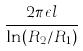<formula> <loc_0><loc_0><loc_500><loc_500>\frac { 2 \pi \epsilon l } { \ln ( R _ { 2 } / R _ { 1 } ) }</formula> 